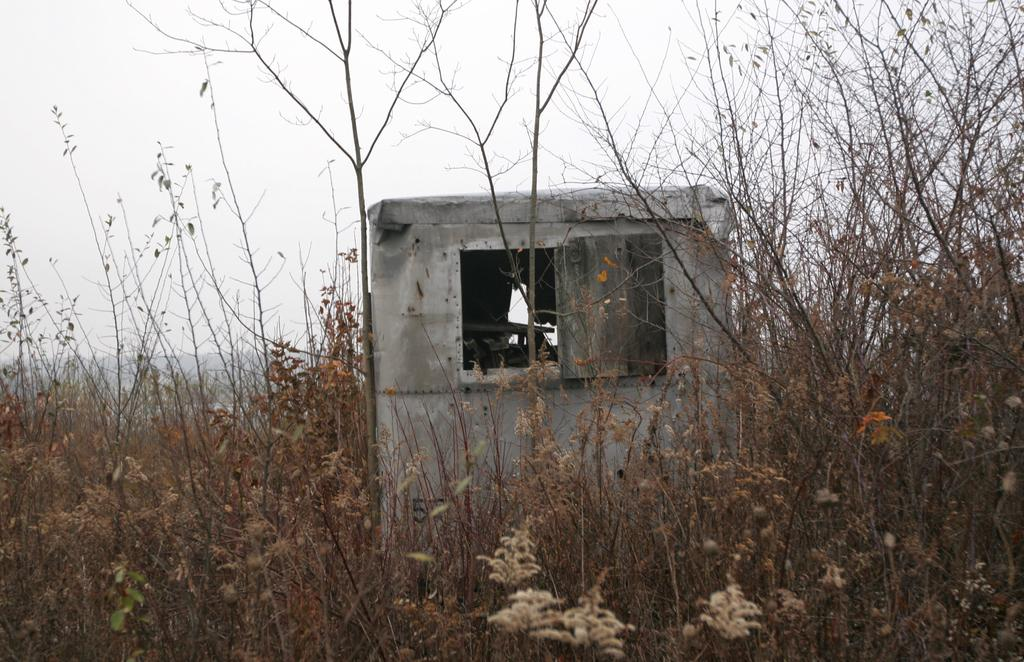Where was the image taken? The image is taken outdoors. What can be seen at the bottom of the image? There are plants at the bottom of the image. What structure is located in the middle of the image? There is a cabin in the middle of the image. What is visible at the top of the image? The sky is visible at the top of the image. How many cars are parked near the cabin in the image? There are no cars visible in the image. What type of plantation can be seen in the background of the image? There is no plantation present in the image. 